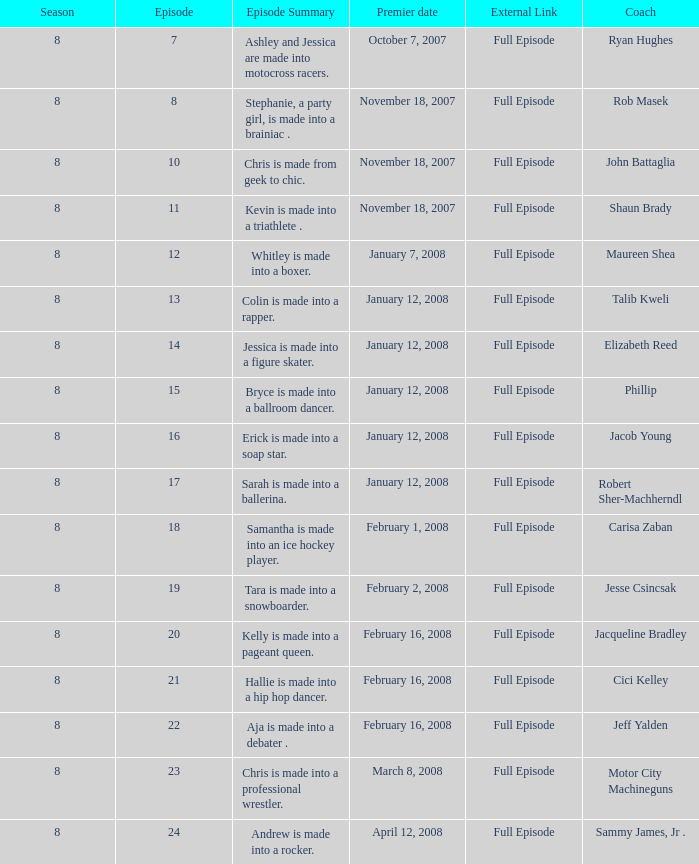0? Jeff Yalden. 